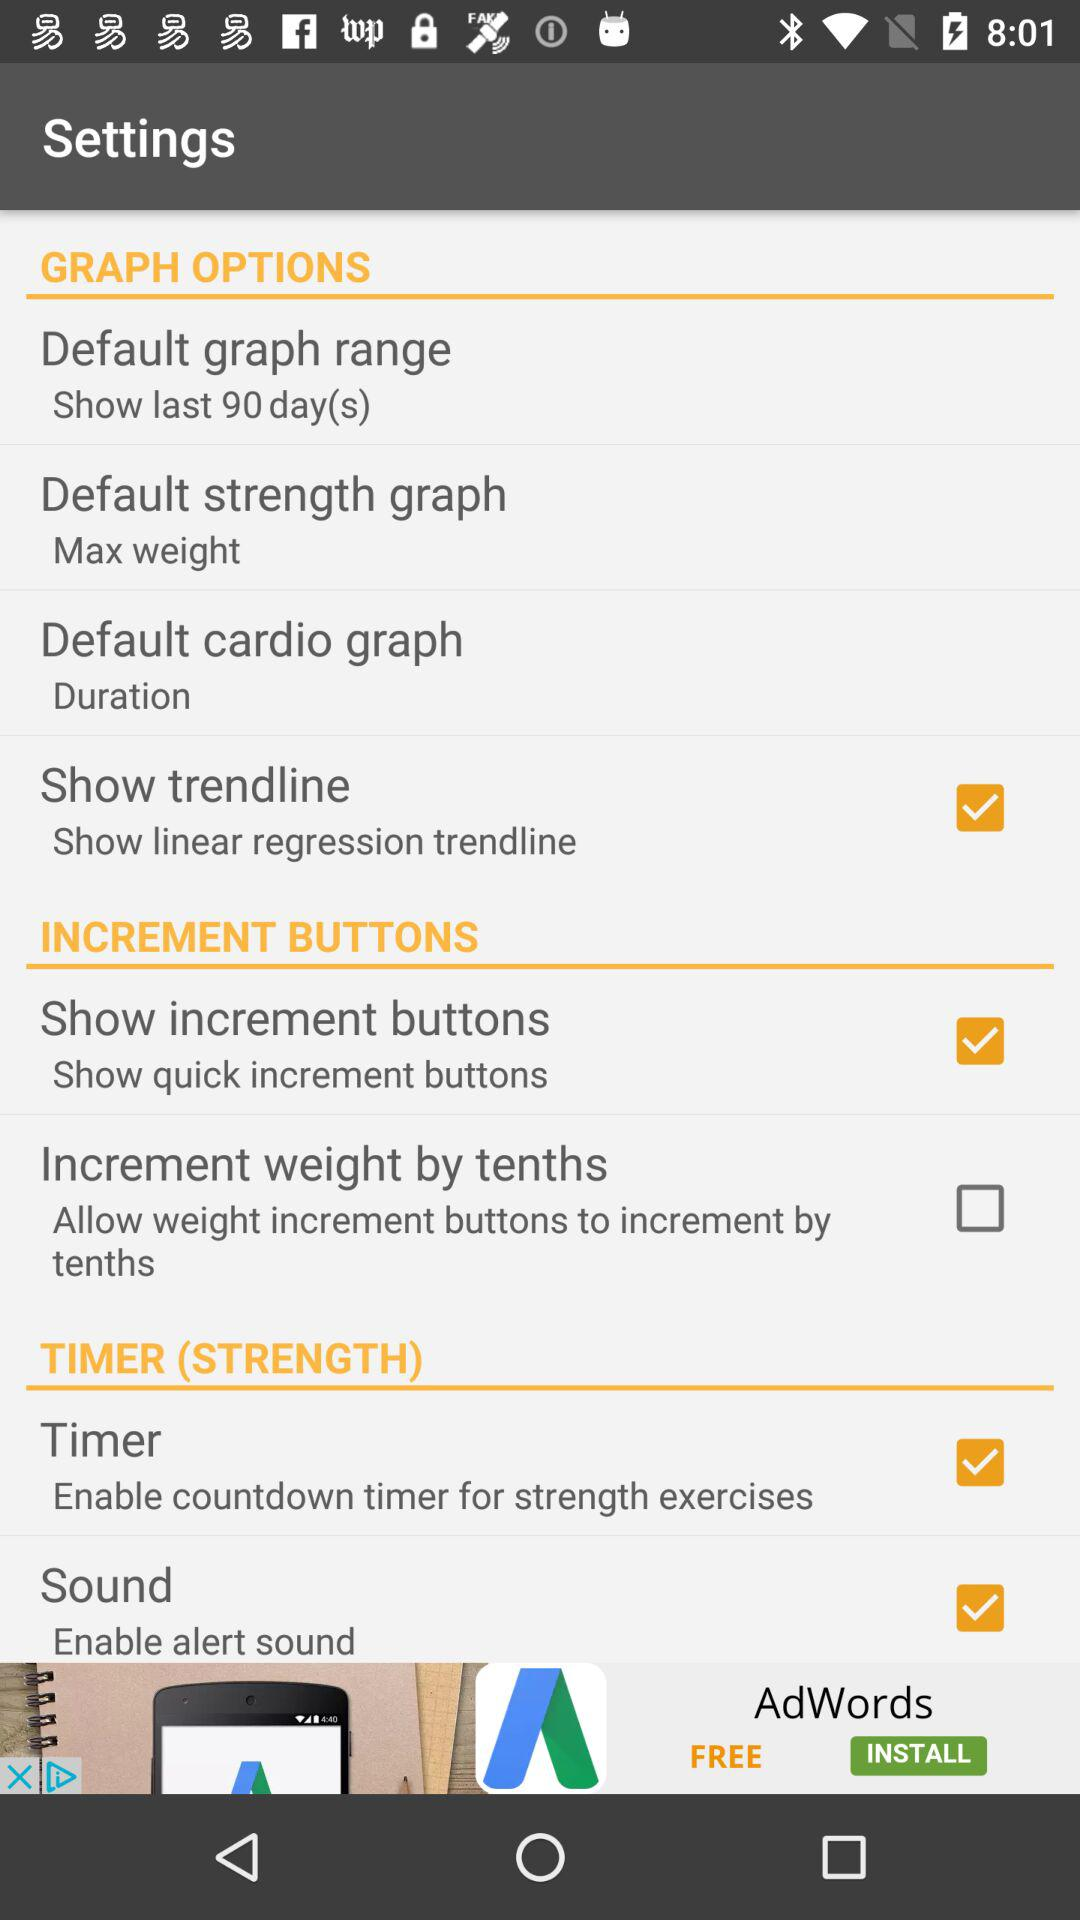What is the status of sound? The status of sound is on. 